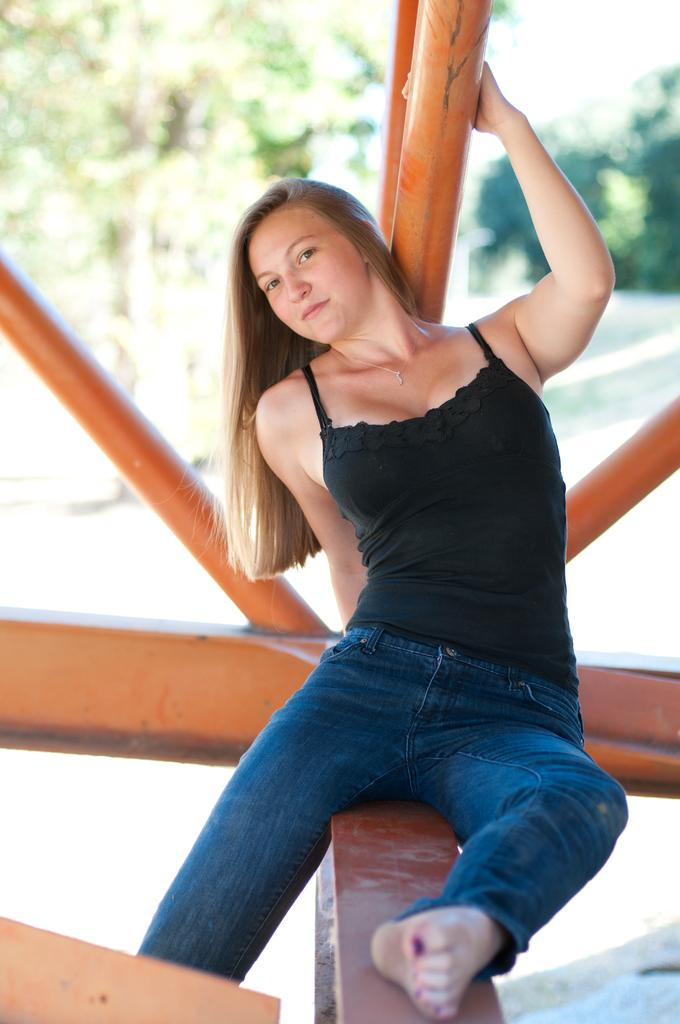Who is present in the image? There is a woman in the image. What is the woman sitting on? The woman is sitting on a wooden platform. What can be seen in the background of the image? There are poles, a road, and trees visible in the background of the image. What type of badge is the woman wearing in the image? There is no badge visible on the woman in the image. What is the woman cooking in the image? There is no indication that the woman is cooking in the image. 